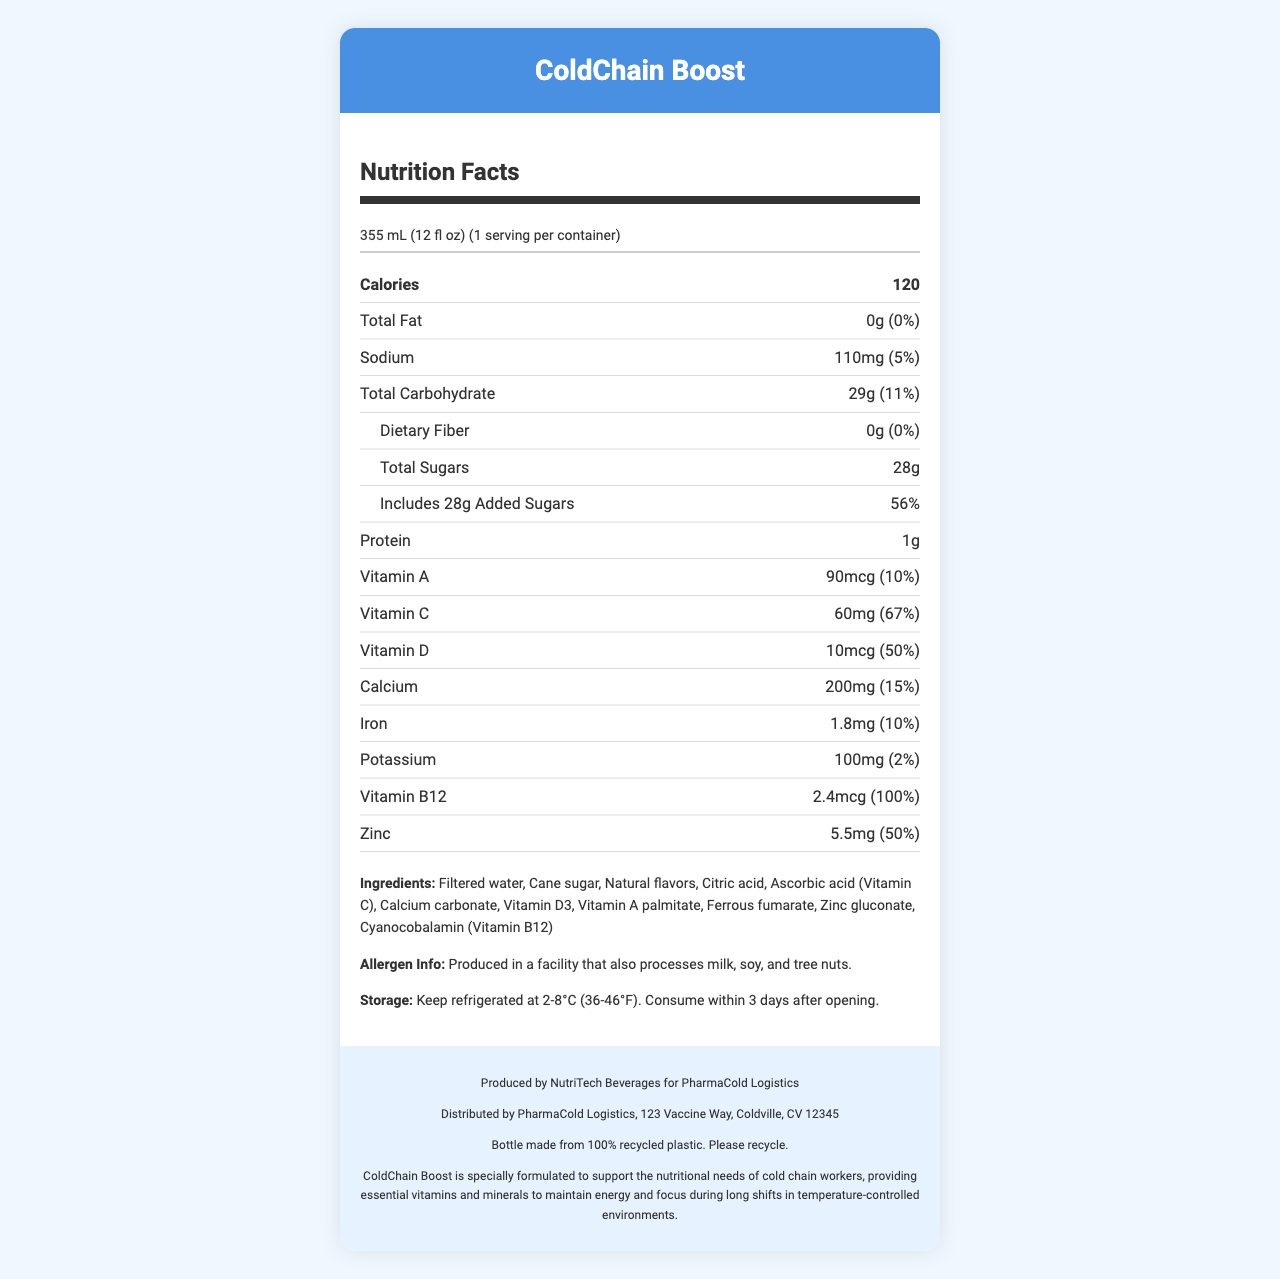what is the serving size for ColdChain Boost? The serving size information is clearly mentioned in the document as "355 mL (12 fl oz)".
Answer: 355 mL (12 fl oz) How many calories are in one serving of ColdChain Boost? The document specifies that there are 120 calories per serving.
Answer: 120 What is the daily value percentage of sodium per serving? The document states that each serving contains 110mg of sodium, which is 5% of the daily value.
Answer: 5% How much Vitamin C does one serving provide? The document provides the amount of Vitamin C as 60mg per serving.
Answer: 60mg Is ColdChain Boost a good source of Vitamin D? The document shows that each serving provides 10mcg of Vitamin D, which is 50% of the daily value, making it a good source.
Answer: Yes Does ColdChain Boost contain any dietary fiber? The document mentions that there is 0g of dietary fiber in each serving.
Answer: No Are there any added sugars in ColdChain Boost? A. None B. 10g C. 28g D. 56g The document lists that there are 28g of added sugars in each serving.
Answer: C. 28g What is the total carbohydrate content per serving? A. 10g B. 20g C. 29g D. 50g The document specifies the total carbohydrate content as 29g per serving.
Answer: C. 29g Does the product contain any zinc? The document specifies that it contains 5.5mg of zinc per serving.
Answer: Yes What should be the storage temperature for ColdChain Boost? The document contains storage instructions that specify the product should be kept refrigerated at 2-8°C (36-46°F).
Answer: 2-8°C (36-46°F) Can ColdChain Boost be consumed by someone with a tree nut allergy without concern? The allergen information indicates that it is produced in a facility that also processes tree nuts, so caution is advised.
Answer: No Describe the main idea of the document. The document provides detailed nutritional facts, ingredients, allergen information, storage instructions, and manufacturer/distributor information about the product ColdChain Boost.
Answer: ColdChain Boost is a fortified beverage designed to support the nutritional needs of cold chain workers. It provides essential vitamins and minerals, should be stored refrigerated, and includes important allergen and sustainability information. Who manufactures ColdChain Boost? The manufacturer information explicitly mentions that the product is produced by NutriTech Beverages for PharmaCold Logistics.
Answer: NutriTech Beverages for PharmaCold Logistics How much protein is in one serving? The document states that each serving contains 1g of protein.
Answer: 1g What is the calcium content in one serving? The document specifies that there is 200mg of calcium per serving.
Answer: 200mg Can I recycle the bottle of ColdChain Boost? The document mentions that the bottle is made from 100% recycled plastic and encourages recycling.
Answer: Yes What are the potential allergens that ColdChain Boost might contain due to cross-contamination? The allergen information indicates that the product is produced in a facility that processes milk, soy, and tree nuts.
Answer: Milk, soy, and tree nuts Where is PharmaCold Logistics located? The distributor information provides this address.
Answer: 123 Vaccine Way, Coldville, CV 12345 Is the exact amount of Vitamin E listed in the document? The document does not mention Vitamin E among the listed nutrients.
Answer: Not enough information What type of acid is included as an ingredient in ColdChain Boost? The ingredient list includes citric acid.
Answer: Citric acid 